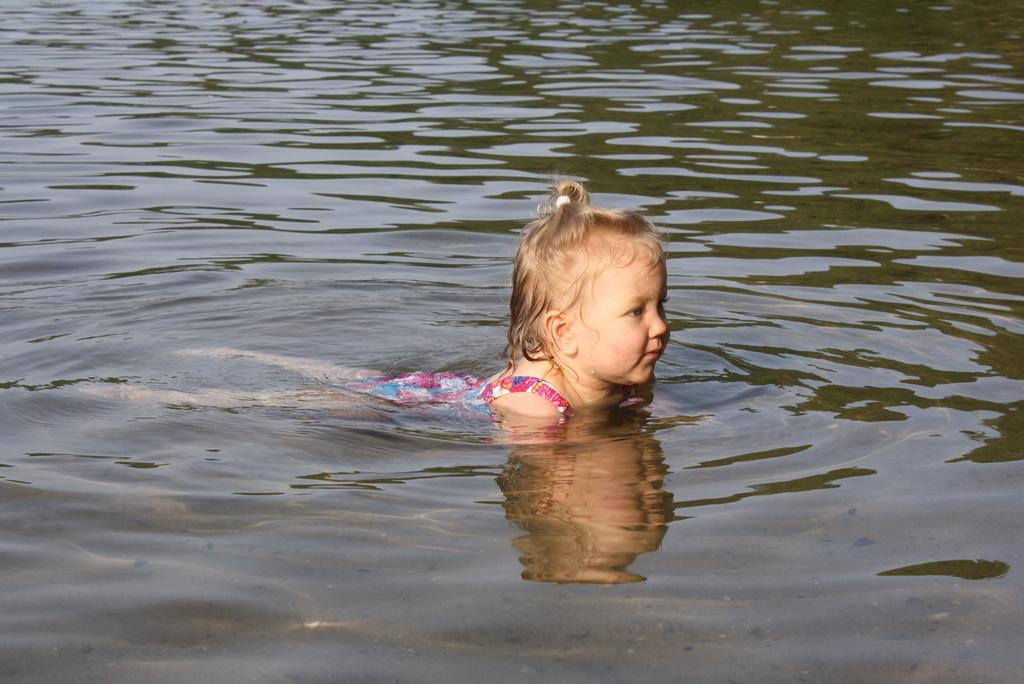What is the main subject of the image? The main subject of the image is a kid in the water. Where is the kid located in the image? The kid is in the water in the center of the image. What type of record can be seen floating in the water next to the goose? There is no record or goose present in the image; it features a kid in the water. 